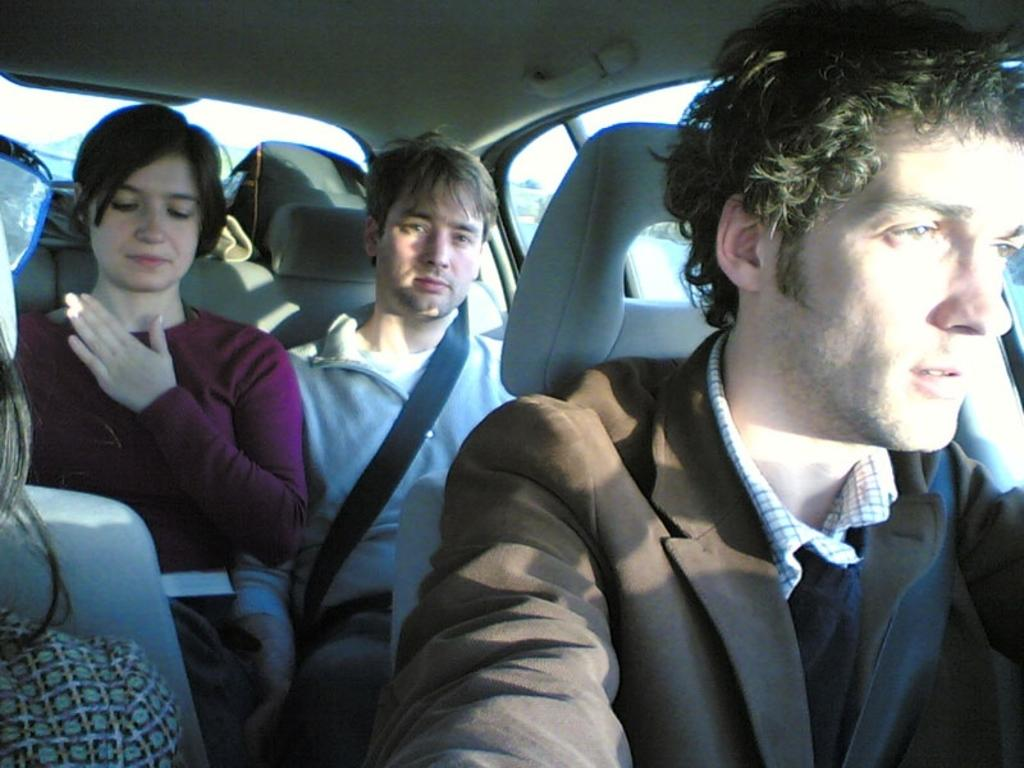What are the people in the image doing? The people in the image are sitting in a car. What can be seen in the background of the image? The sky and trees are visible in the background of the image. What type of celery is being used as a waste disposal system in the image? There is no celery or waste disposal system present in the image. 